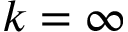Convert formula to latex. <formula><loc_0><loc_0><loc_500><loc_500>k = \infty</formula> 